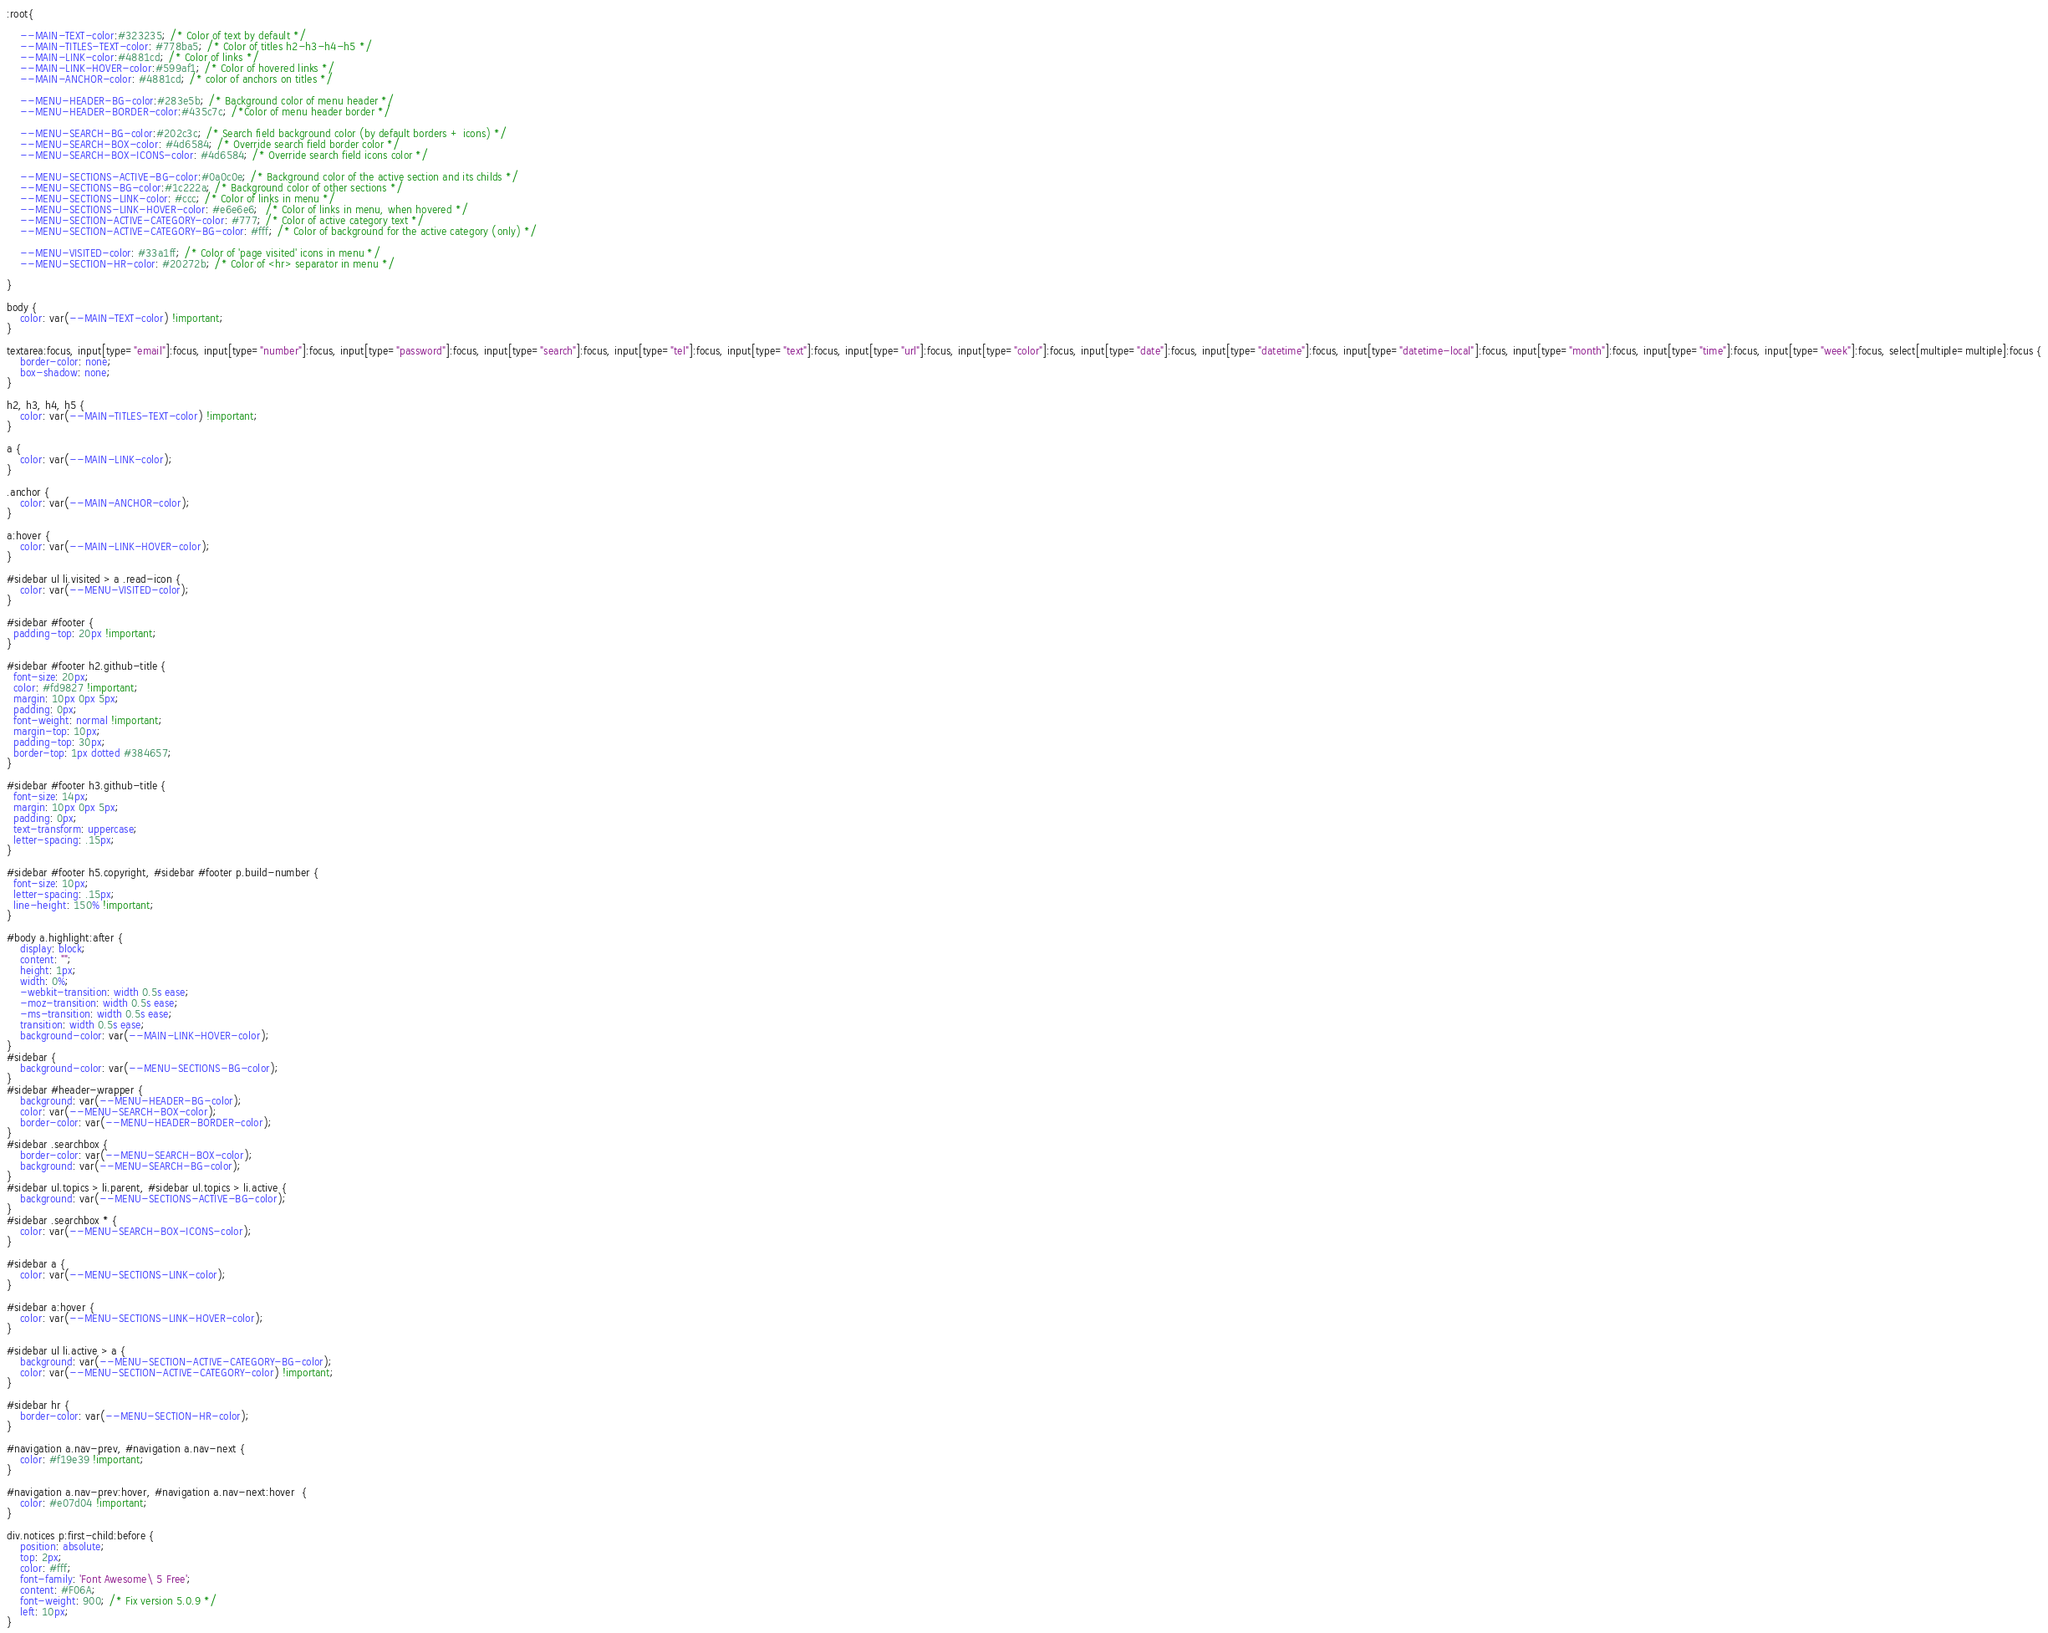Convert code to text. <code><loc_0><loc_0><loc_500><loc_500><_CSS_>
:root{

    --MAIN-TEXT-color:#323235; /* Color of text by default */
    --MAIN-TITLES-TEXT-color: #778ba5; /* Color of titles h2-h3-h4-h5 */
    --MAIN-LINK-color:#4881cd; /* Color of links */
    --MAIN-LINK-HOVER-color:#599af1; /* Color of hovered links */
    --MAIN-ANCHOR-color: #4881cd; /* color of anchors on titles */

    --MENU-HEADER-BG-color:#283e5b; /* Background color of menu header */
    --MENU-HEADER-BORDER-color:#435c7c; /*Color of menu header border */

    --MENU-SEARCH-BG-color:#202c3c; /* Search field background color (by default borders + icons) */
    --MENU-SEARCH-BOX-color: #4d6584; /* Override search field border color */
    --MENU-SEARCH-BOX-ICONS-color: #4d6584; /* Override search field icons color */

    --MENU-SECTIONS-ACTIVE-BG-color:#0a0c0e; /* Background color of the active section and its childs */
    --MENU-SECTIONS-BG-color:#1c222a; /* Background color of other sections */
    --MENU-SECTIONS-LINK-color: #ccc; /* Color of links in menu */
    --MENU-SECTIONS-LINK-HOVER-color: #e6e6e6;  /* Color of links in menu, when hovered */
    --MENU-SECTION-ACTIVE-CATEGORY-color: #777; /* Color of active category text */
    --MENU-SECTION-ACTIVE-CATEGORY-BG-color: #fff; /* Color of background for the active category (only) */

    --MENU-VISITED-color: #33a1ff; /* Color of 'page visited' icons in menu */
    --MENU-SECTION-HR-color: #20272b; /* Color of <hr> separator in menu */

}

body {
    color: var(--MAIN-TEXT-color) !important;
}

textarea:focus, input[type="email"]:focus, input[type="number"]:focus, input[type="password"]:focus, input[type="search"]:focus, input[type="tel"]:focus, input[type="text"]:focus, input[type="url"]:focus, input[type="color"]:focus, input[type="date"]:focus, input[type="datetime"]:focus, input[type="datetime-local"]:focus, input[type="month"]:focus, input[type="time"]:focus, input[type="week"]:focus, select[multiple=multiple]:focus {
    border-color: none;
    box-shadow: none;
}

h2, h3, h4, h5 {
    color: var(--MAIN-TITLES-TEXT-color) !important;
}

a {
    color: var(--MAIN-LINK-color);
}

.anchor {
    color: var(--MAIN-ANCHOR-color);
}

a:hover {
    color: var(--MAIN-LINK-HOVER-color);
}

#sidebar ul li.visited > a .read-icon {
	color: var(--MENU-VISITED-color);
}

#sidebar #footer {
  padding-top: 20px !important;
}

#sidebar #footer h2.github-title {
  font-size: 20px;
  color: #fd9827 !important;
  margin: 10px 0px 5px;
  padding: 0px;
  font-weight: normal !important;
  margin-top: 10px;
  padding-top: 30px;
  border-top: 1px dotted #384657;
}

#sidebar #footer h3.github-title {
  font-size: 14px;
  margin: 10px 0px 5px;
  padding: 0px;
  text-transform: uppercase;
  letter-spacing: .15px;
}

#sidebar #footer h5.copyright, #sidebar #footer p.build-number {
  font-size: 10px;
  letter-spacing: .15px;
  line-height: 150% !important;
}

#body a.highlight:after {
    display: block;
    content: "";
    height: 1px;
    width: 0%;
    -webkit-transition: width 0.5s ease;
    -moz-transition: width 0.5s ease;
    -ms-transition: width 0.5s ease;
    transition: width 0.5s ease;
    background-color: var(--MAIN-LINK-HOVER-color);
}
#sidebar {
	background-color: var(--MENU-SECTIONS-BG-color);
}
#sidebar #header-wrapper {
    background: var(--MENU-HEADER-BG-color);
    color: var(--MENU-SEARCH-BOX-color);
    border-color: var(--MENU-HEADER-BORDER-color);
}
#sidebar .searchbox {
	border-color: var(--MENU-SEARCH-BOX-color);
    background: var(--MENU-SEARCH-BG-color);
}
#sidebar ul.topics > li.parent, #sidebar ul.topics > li.active {
    background: var(--MENU-SECTIONS-ACTIVE-BG-color);
}
#sidebar .searchbox * {
    color: var(--MENU-SEARCH-BOX-ICONS-color);
}

#sidebar a {
    color: var(--MENU-SECTIONS-LINK-color);
}

#sidebar a:hover {
    color: var(--MENU-SECTIONS-LINK-HOVER-color);
}

#sidebar ul li.active > a {
    background: var(--MENU-SECTION-ACTIVE-CATEGORY-BG-color);
    color: var(--MENU-SECTION-ACTIVE-CATEGORY-color) !important;
}

#sidebar hr {
    border-color: var(--MENU-SECTION-HR-color);
}

#navigation a.nav-prev, #navigation a.nav-next {
    color: #f19e39 !important;
}

#navigation a.nav-prev:hover, #navigation a.nav-next:hover  {
    color: #e07d04 !important;
}

div.notices p:first-child:before {
    position: absolute;
    top: 2px;
    color: #fff;
    font-family: 'Font Awesome\ 5 Free';
    content: #F06A;
    font-weight: 900; /* Fix version 5.0.9 */
    left: 10px;
}
</code> 